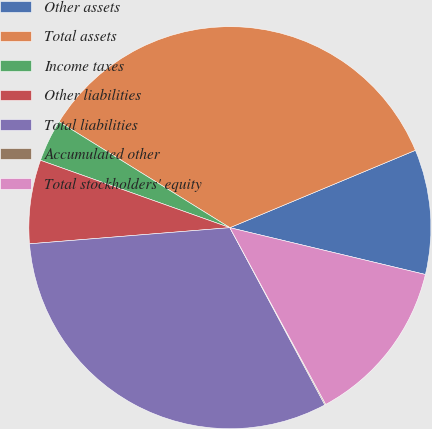Convert chart. <chart><loc_0><loc_0><loc_500><loc_500><pie_chart><fcel>Other assets<fcel>Total assets<fcel>Income taxes<fcel>Other liabilities<fcel>Total liabilities<fcel>Accumulated other<fcel>Total stockholders' equity<nl><fcel>10.03%<fcel>34.87%<fcel>3.4%<fcel>6.72%<fcel>31.55%<fcel>0.08%<fcel>13.35%<nl></chart> 